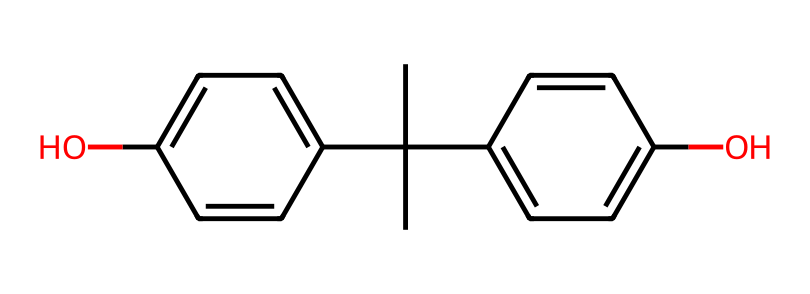What is the chemical name of this structure? The SMILES representation corresponds to a chemical known as bisphenol A. Its structure features two hydroxyl groups (-OH) attached to two phenol rings. Recognizing the combination of the phenol groups gives the full name.
Answer: bisphenol A How many carbon atoms are in bisphenol A? In the SMILES representation, we can count all the carbon atoms present in the structure. There are 15 carbon atoms, identified by each 'C' in the SMILES.
Answer: 15 How many hydroxyl groups does bisphenol A contain? The presence of hydroxyl groups can be identified by looking for the -OH functional groups in the structure. In this case, bisphenol A has two -OH groups.
Answer: 2 What type of chemical compound is bisphenol A categorized as? Bisphenol A is categorized as a phenolic compound due to its structure, which includes hydroxyl groups attached to aromatic rings. This classification highlights its properties as a phenol.
Answer: phenolic Which functional groups are present in bisphenol A? The key functional groups in this structure are the hydroxyl (-OH) groups. By analyzing the molecular structure, we can identify two -OH groups that contribute to its phenolic nature.
Answer: hydroxyl groups How many aromatic rings does bisphenol A have? The structure consists of two distinct aromatic rings, as seen in the phenol components attached to the molecule. Each circle in the benzene ring is indicative of aromaticity.
Answer: 2 What is a primary use of bisphenol A? A primary use of bisphenol A is in the production of polycarbonate plastics and epoxy resins. This is a well-known application within industry and manufacturing.
Answer: polycarbonate plastics 